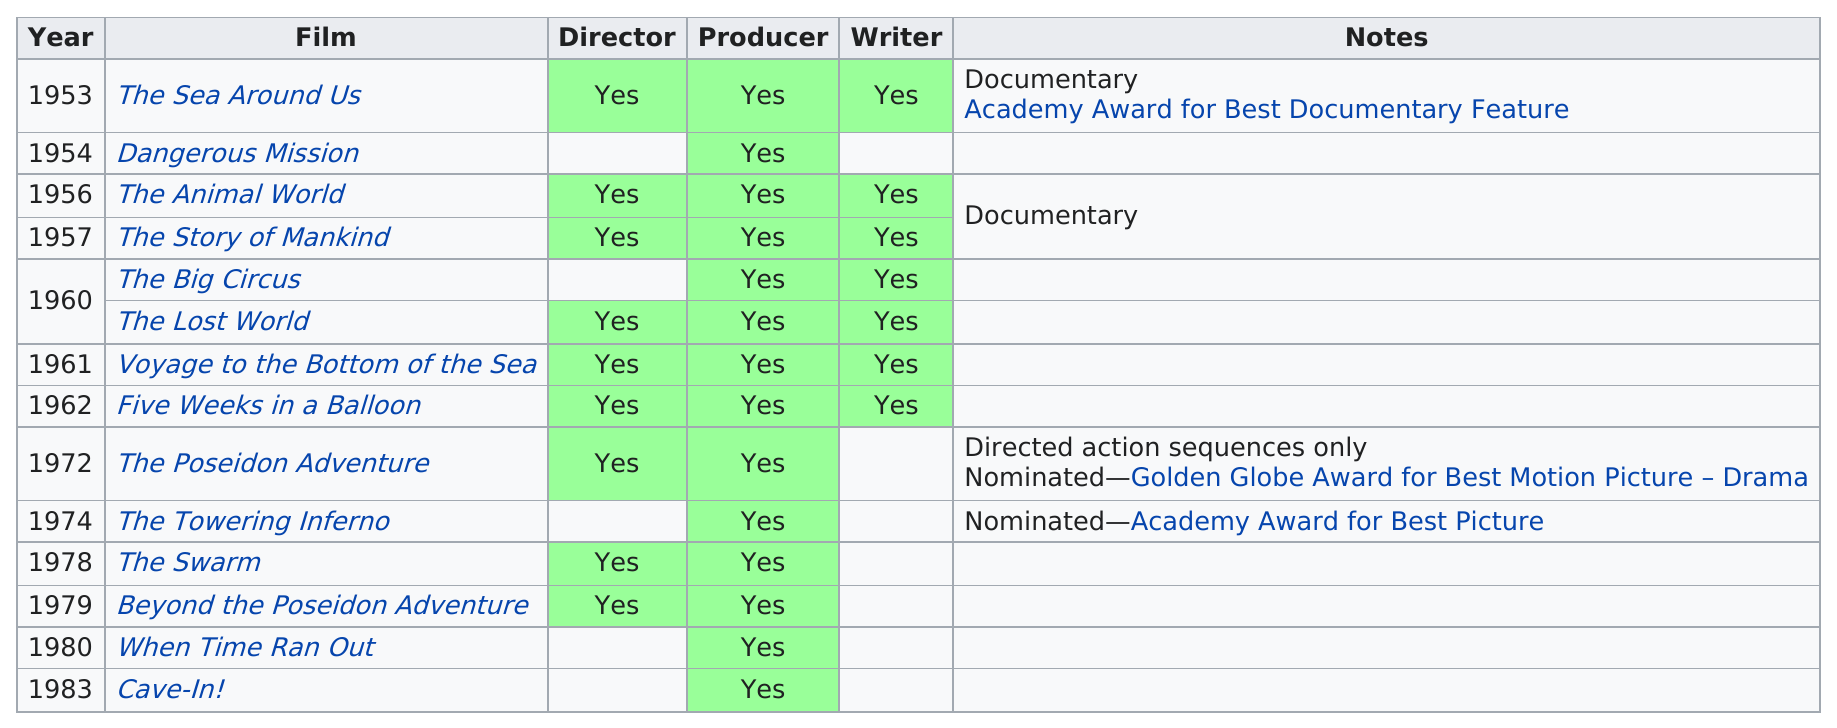Indicate a few pertinent items in this graphic. Irwin Allen was involved in a total of 8 films before 1973. Irwin Allen directed, produced, and wrote six films. 